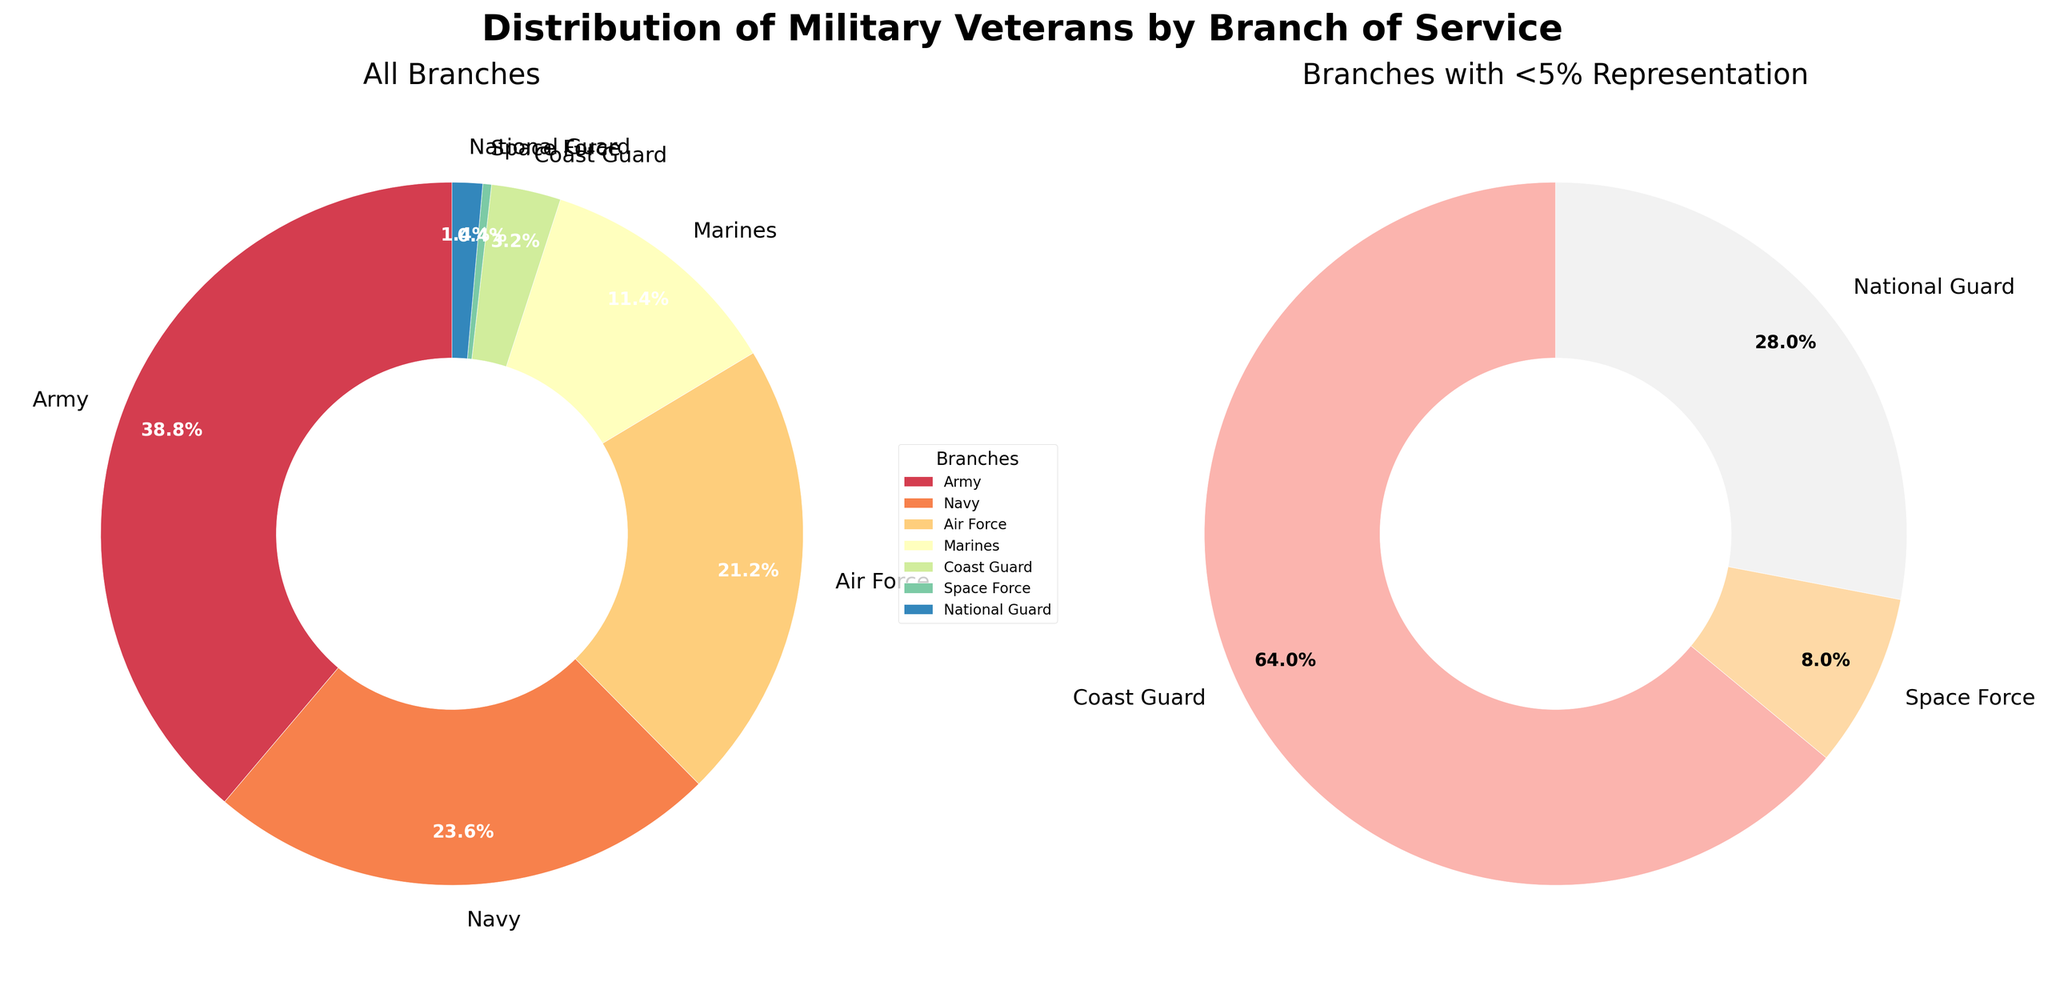What is the title of the figure? The title of the figure is displayed at the top and reads 'Distribution of Military Veterans by Branch of Service'.
Answer: Distribution of Military Veterans by Branch of Service Which branch has the highest percentage of veterans? By looking at the main pie chart, the largest segment belongs to the Army, represented by 38.8%.
Answer: Army What is the combined percentage of the Navy and Air Force veterans? According to the main pie chart, the Navy has 23.6% and the Air Force has 21.2%. Adding these percentages together gives 23.6% + 21.2% = 44.8%.
Answer: 44.8% Which branches are displayed in the smaller pie chart? The smaller pie chart focuses on branches with less than 5% representation. Examining the legend, these branches include the Coast Guard, Space Force, and National Guard.
Answer: Coast Guard, Space Force, National Guard How much larger is the percentage of Army veterans compared to Marine veterans? The percentage of Army veterans is 38.8% while the percentage of Marine veterans is 11.4%. The difference is calculated as 38.8% - 11.4% = 27.4%.
Answer: 27.4% Which branch has the smallest percentage of veterans? The smallest segment in the main pie chart and the smaller pie chart is the Space Force, represented by 0.4%.
Answer: Space Force What is the percentage of Coast Guard veterans? Looking at the larger pie chart, the Coast Guard segment corresponds to 3.2% of the total.
Answer: 3.2% What is the title of the smaller pie chart? The smaller pie chart's title, found above the chart, reads 'Branches with <5% Representation'.
Answer: Branches with <5% Representation How many branches have more than 20% representation? From the main pie chart, only the Army (38.8%), Navy (23.6%), and Air Force (21.2%) segments are above 20%. Therefore, there are three branches.
Answer: 3 Which branch has a higher percentage of veterans: Navy or Marines? From the main pie chart, the Navy has 23.6% while the Marines have 11.4%. Thus, the Navy has a higher percentage.
Answer: Navy 